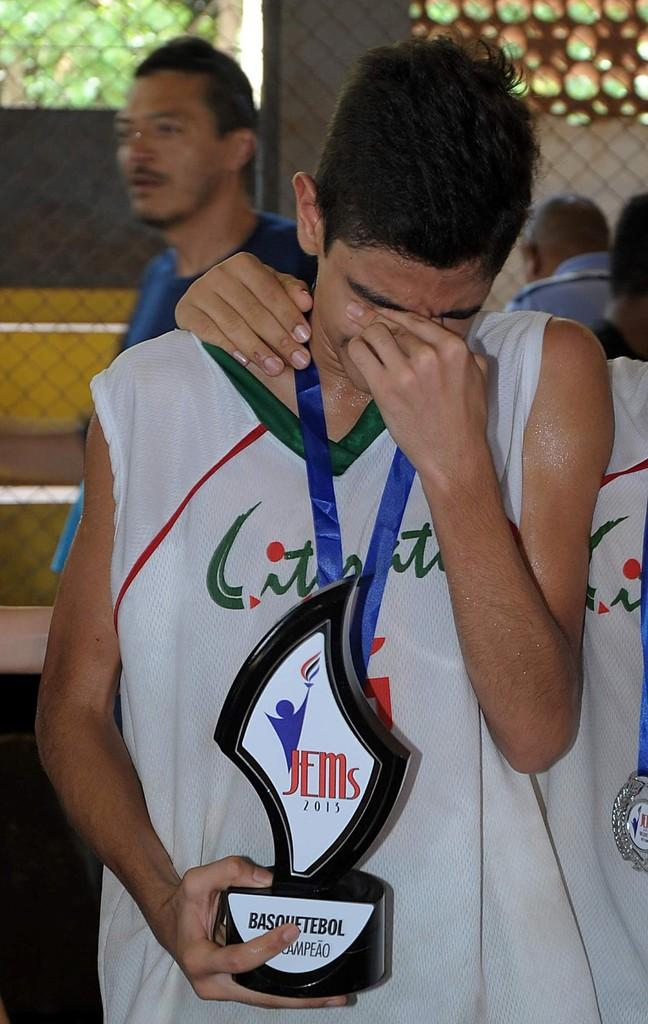<image>
Provide a brief description of the given image. a boy crying with a JEMs trophy in his hand 